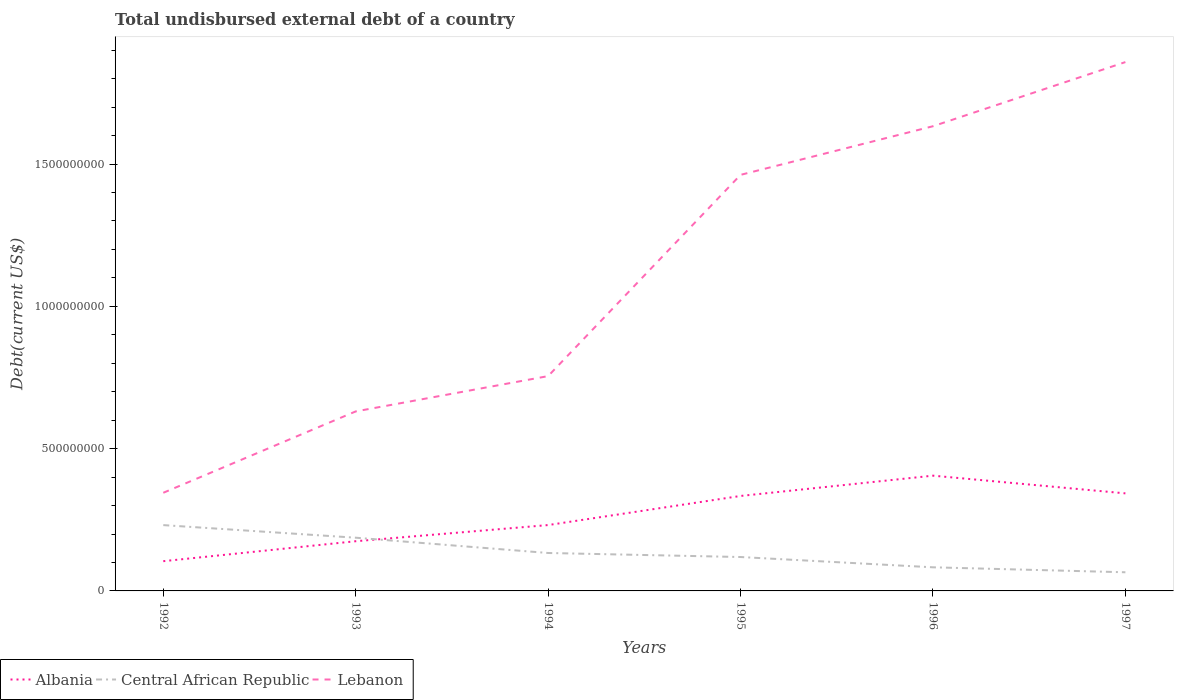Across all years, what is the maximum total undisbursed external debt in Albania?
Provide a short and direct response. 1.05e+08. What is the total total undisbursed external debt in Lebanon in the graph?
Your answer should be compact. -1.71e+08. What is the difference between the highest and the second highest total undisbursed external debt in Lebanon?
Offer a terse response. 1.51e+09. What is the difference between the highest and the lowest total undisbursed external debt in Central African Republic?
Offer a terse response. 2. How many years are there in the graph?
Ensure brevity in your answer.  6. Does the graph contain grids?
Give a very brief answer. No. How are the legend labels stacked?
Your response must be concise. Horizontal. What is the title of the graph?
Give a very brief answer. Total undisbursed external debt of a country. Does "Vanuatu" appear as one of the legend labels in the graph?
Ensure brevity in your answer.  No. What is the label or title of the X-axis?
Provide a succinct answer. Years. What is the label or title of the Y-axis?
Keep it short and to the point. Debt(current US$). What is the Debt(current US$) in Albania in 1992?
Keep it short and to the point. 1.05e+08. What is the Debt(current US$) in Central African Republic in 1992?
Keep it short and to the point. 2.31e+08. What is the Debt(current US$) in Lebanon in 1992?
Make the answer very short. 3.45e+08. What is the Debt(current US$) of Albania in 1993?
Your answer should be very brief. 1.75e+08. What is the Debt(current US$) of Central African Republic in 1993?
Give a very brief answer. 1.87e+08. What is the Debt(current US$) of Lebanon in 1993?
Your answer should be compact. 6.31e+08. What is the Debt(current US$) of Albania in 1994?
Your answer should be very brief. 2.31e+08. What is the Debt(current US$) of Central African Republic in 1994?
Your response must be concise. 1.33e+08. What is the Debt(current US$) of Lebanon in 1994?
Provide a short and direct response. 7.55e+08. What is the Debt(current US$) of Albania in 1995?
Give a very brief answer. 3.34e+08. What is the Debt(current US$) in Central African Republic in 1995?
Offer a terse response. 1.19e+08. What is the Debt(current US$) in Lebanon in 1995?
Give a very brief answer. 1.46e+09. What is the Debt(current US$) of Albania in 1996?
Offer a terse response. 4.05e+08. What is the Debt(current US$) of Central African Republic in 1996?
Your answer should be compact. 8.30e+07. What is the Debt(current US$) of Lebanon in 1996?
Offer a very short reply. 1.63e+09. What is the Debt(current US$) in Albania in 1997?
Give a very brief answer. 3.43e+08. What is the Debt(current US$) in Central African Republic in 1997?
Offer a very short reply. 6.55e+07. What is the Debt(current US$) in Lebanon in 1997?
Your answer should be very brief. 1.86e+09. Across all years, what is the maximum Debt(current US$) of Albania?
Give a very brief answer. 4.05e+08. Across all years, what is the maximum Debt(current US$) of Central African Republic?
Offer a terse response. 2.31e+08. Across all years, what is the maximum Debt(current US$) in Lebanon?
Provide a succinct answer. 1.86e+09. Across all years, what is the minimum Debt(current US$) in Albania?
Keep it short and to the point. 1.05e+08. Across all years, what is the minimum Debt(current US$) in Central African Republic?
Your response must be concise. 6.55e+07. Across all years, what is the minimum Debt(current US$) of Lebanon?
Offer a terse response. 3.45e+08. What is the total Debt(current US$) in Albania in the graph?
Offer a very short reply. 1.59e+09. What is the total Debt(current US$) of Central African Republic in the graph?
Keep it short and to the point. 8.19e+08. What is the total Debt(current US$) of Lebanon in the graph?
Your answer should be compact. 6.68e+09. What is the difference between the Debt(current US$) in Albania in 1992 and that in 1993?
Your response must be concise. -7.02e+07. What is the difference between the Debt(current US$) in Central African Republic in 1992 and that in 1993?
Offer a very short reply. 4.43e+07. What is the difference between the Debt(current US$) of Lebanon in 1992 and that in 1993?
Your answer should be compact. -2.86e+08. What is the difference between the Debt(current US$) in Albania in 1992 and that in 1994?
Offer a terse response. -1.27e+08. What is the difference between the Debt(current US$) of Central African Republic in 1992 and that in 1994?
Your response must be concise. 9.80e+07. What is the difference between the Debt(current US$) of Lebanon in 1992 and that in 1994?
Your response must be concise. -4.10e+08. What is the difference between the Debt(current US$) of Albania in 1992 and that in 1995?
Provide a succinct answer. -2.29e+08. What is the difference between the Debt(current US$) of Central African Republic in 1992 and that in 1995?
Provide a short and direct response. 1.12e+08. What is the difference between the Debt(current US$) of Lebanon in 1992 and that in 1995?
Give a very brief answer. -1.12e+09. What is the difference between the Debt(current US$) in Albania in 1992 and that in 1996?
Provide a succinct answer. -3.01e+08. What is the difference between the Debt(current US$) in Central African Republic in 1992 and that in 1996?
Your answer should be very brief. 1.48e+08. What is the difference between the Debt(current US$) in Lebanon in 1992 and that in 1996?
Your answer should be very brief. -1.29e+09. What is the difference between the Debt(current US$) of Albania in 1992 and that in 1997?
Ensure brevity in your answer.  -2.38e+08. What is the difference between the Debt(current US$) in Central African Republic in 1992 and that in 1997?
Offer a terse response. 1.66e+08. What is the difference between the Debt(current US$) of Lebanon in 1992 and that in 1997?
Keep it short and to the point. -1.51e+09. What is the difference between the Debt(current US$) of Albania in 1993 and that in 1994?
Provide a succinct answer. -5.68e+07. What is the difference between the Debt(current US$) in Central African Republic in 1993 and that in 1994?
Offer a terse response. 5.37e+07. What is the difference between the Debt(current US$) in Lebanon in 1993 and that in 1994?
Offer a terse response. -1.24e+08. What is the difference between the Debt(current US$) in Albania in 1993 and that in 1995?
Ensure brevity in your answer.  -1.59e+08. What is the difference between the Debt(current US$) of Central African Republic in 1993 and that in 1995?
Provide a short and direct response. 6.79e+07. What is the difference between the Debt(current US$) of Lebanon in 1993 and that in 1995?
Give a very brief answer. -8.31e+08. What is the difference between the Debt(current US$) in Albania in 1993 and that in 1996?
Your response must be concise. -2.30e+08. What is the difference between the Debt(current US$) in Central African Republic in 1993 and that in 1996?
Ensure brevity in your answer.  1.04e+08. What is the difference between the Debt(current US$) of Lebanon in 1993 and that in 1996?
Your answer should be compact. -1.00e+09. What is the difference between the Debt(current US$) in Albania in 1993 and that in 1997?
Your answer should be very brief. -1.68e+08. What is the difference between the Debt(current US$) of Central African Republic in 1993 and that in 1997?
Your answer should be very brief. 1.21e+08. What is the difference between the Debt(current US$) of Lebanon in 1993 and that in 1997?
Offer a very short reply. -1.23e+09. What is the difference between the Debt(current US$) in Albania in 1994 and that in 1995?
Your answer should be compact. -1.02e+08. What is the difference between the Debt(current US$) in Central African Republic in 1994 and that in 1995?
Give a very brief answer. 1.42e+07. What is the difference between the Debt(current US$) of Lebanon in 1994 and that in 1995?
Your answer should be compact. -7.07e+08. What is the difference between the Debt(current US$) of Albania in 1994 and that in 1996?
Make the answer very short. -1.74e+08. What is the difference between the Debt(current US$) of Central African Republic in 1994 and that in 1996?
Keep it short and to the point. 5.03e+07. What is the difference between the Debt(current US$) in Lebanon in 1994 and that in 1996?
Provide a short and direct response. -8.78e+08. What is the difference between the Debt(current US$) of Albania in 1994 and that in 1997?
Provide a short and direct response. -1.11e+08. What is the difference between the Debt(current US$) of Central African Republic in 1994 and that in 1997?
Ensure brevity in your answer.  6.78e+07. What is the difference between the Debt(current US$) of Lebanon in 1994 and that in 1997?
Offer a terse response. -1.10e+09. What is the difference between the Debt(current US$) of Albania in 1995 and that in 1996?
Provide a succinct answer. -7.13e+07. What is the difference between the Debt(current US$) of Central African Republic in 1995 and that in 1996?
Keep it short and to the point. 3.62e+07. What is the difference between the Debt(current US$) in Lebanon in 1995 and that in 1996?
Make the answer very short. -1.71e+08. What is the difference between the Debt(current US$) in Albania in 1995 and that in 1997?
Your response must be concise. -9.08e+06. What is the difference between the Debt(current US$) of Central African Republic in 1995 and that in 1997?
Your answer should be very brief. 5.36e+07. What is the difference between the Debt(current US$) of Lebanon in 1995 and that in 1997?
Ensure brevity in your answer.  -3.96e+08. What is the difference between the Debt(current US$) in Albania in 1996 and that in 1997?
Your answer should be compact. 6.22e+07. What is the difference between the Debt(current US$) in Central African Republic in 1996 and that in 1997?
Give a very brief answer. 1.74e+07. What is the difference between the Debt(current US$) in Lebanon in 1996 and that in 1997?
Offer a very short reply. -2.25e+08. What is the difference between the Debt(current US$) of Albania in 1992 and the Debt(current US$) of Central African Republic in 1993?
Provide a short and direct response. -8.25e+07. What is the difference between the Debt(current US$) in Albania in 1992 and the Debt(current US$) in Lebanon in 1993?
Make the answer very short. -5.26e+08. What is the difference between the Debt(current US$) of Central African Republic in 1992 and the Debt(current US$) of Lebanon in 1993?
Provide a short and direct response. -4.00e+08. What is the difference between the Debt(current US$) of Albania in 1992 and the Debt(current US$) of Central African Republic in 1994?
Keep it short and to the point. -2.88e+07. What is the difference between the Debt(current US$) in Albania in 1992 and the Debt(current US$) in Lebanon in 1994?
Provide a short and direct response. -6.50e+08. What is the difference between the Debt(current US$) of Central African Republic in 1992 and the Debt(current US$) of Lebanon in 1994?
Give a very brief answer. -5.24e+08. What is the difference between the Debt(current US$) of Albania in 1992 and the Debt(current US$) of Central African Republic in 1995?
Your answer should be compact. -1.46e+07. What is the difference between the Debt(current US$) of Albania in 1992 and the Debt(current US$) of Lebanon in 1995?
Ensure brevity in your answer.  -1.36e+09. What is the difference between the Debt(current US$) of Central African Republic in 1992 and the Debt(current US$) of Lebanon in 1995?
Ensure brevity in your answer.  -1.23e+09. What is the difference between the Debt(current US$) in Albania in 1992 and the Debt(current US$) in Central African Republic in 1996?
Your answer should be very brief. 2.15e+07. What is the difference between the Debt(current US$) of Albania in 1992 and the Debt(current US$) of Lebanon in 1996?
Make the answer very short. -1.53e+09. What is the difference between the Debt(current US$) in Central African Republic in 1992 and the Debt(current US$) in Lebanon in 1996?
Your response must be concise. -1.40e+09. What is the difference between the Debt(current US$) in Albania in 1992 and the Debt(current US$) in Central African Republic in 1997?
Provide a short and direct response. 3.90e+07. What is the difference between the Debt(current US$) in Albania in 1992 and the Debt(current US$) in Lebanon in 1997?
Your answer should be compact. -1.75e+09. What is the difference between the Debt(current US$) of Central African Republic in 1992 and the Debt(current US$) of Lebanon in 1997?
Provide a short and direct response. -1.63e+09. What is the difference between the Debt(current US$) in Albania in 1993 and the Debt(current US$) in Central African Republic in 1994?
Your answer should be very brief. 4.14e+07. What is the difference between the Debt(current US$) of Albania in 1993 and the Debt(current US$) of Lebanon in 1994?
Offer a very short reply. -5.80e+08. What is the difference between the Debt(current US$) of Central African Republic in 1993 and the Debt(current US$) of Lebanon in 1994?
Provide a succinct answer. -5.68e+08. What is the difference between the Debt(current US$) in Albania in 1993 and the Debt(current US$) in Central African Republic in 1995?
Provide a short and direct response. 5.55e+07. What is the difference between the Debt(current US$) in Albania in 1993 and the Debt(current US$) in Lebanon in 1995?
Ensure brevity in your answer.  -1.29e+09. What is the difference between the Debt(current US$) in Central African Republic in 1993 and the Debt(current US$) in Lebanon in 1995?
Give a very brief answer. -1.28e+09. What is the difference between the Debt(current US$) in Albania in 1993 and the Debt(current US$) in Central African Republic in 1996?
Offer a very short reply. 9.17e+07. What is the difference between the Debt(current US$) of Albania in 1993 and the Debt(current US$) of Lebanon in 1996?
Provide a succinct answer. -1.46e+09. What is the difference between the Debt(current US$) of Central African Republic in 1993 and the Debt(current US$) of Lebanon in 1996?
Provide a short and direct response. -1.45e+09. What is the difference between the Debt(current US$) in Albania in 1993 and the Debt(current US$) in Central African Republic in 1997?
Make the answer very short. 1.09e+08. What is the difference between the Debt(current US$) in Albania in 1993 and the Debt(current US$) in Lebanon in 1997?
Keep it short and to the point. -1.68e+09. What is the difference between the Debt(current US$) of Central African Republic in 1993 and the Debt(current US$) of Lebanon in 1997?
Offer a very short reply. -1.67e+09. What is the difference between the Debt(current US$) of Albania in 1994 and the Debt(current US$) of Central African Republic in 1995?
Your response must be concise. 1.12e+08. What is the difference between the Debt(current US$) in Albania in 1994 and the Debt(current US$) in Lebanon in 1995?
Ensure brevity in your answer.  -1.23e+09. What is the difference between the Debt(current US$) in Central African Republic in 1994 and the Debt(current US$) in Lebanon in 1995?
Offer a very short reply. -1.33e+09. What is the difference between the Debt(current US$) of Albania in 1994 and the Debt(current US$) of Central African Republic in 1996?
Your answer should be very brief. 1.48e+08. What is the difference between the Debt(current US$) of Albania in 1994 and the Debt(current US$) of Lebanon in 1996?
Offer a very short reply. -1.40e+09. What is the difference between the Debt(current US$) of Central African Republic in 1994 and the Debt(current US$) of Lebanon in 1996?
Your answer should be compact. -1.50e+09. What is the difference between the Debt(current US$) of Albania in 1994 and the Debt(current US$) of Central African Republic in 1997?
Ensure brevity in your answer.  1.66e+08. What is the difference between the Debt(current US$) in Albania in 1994 and the Debt(current US$) in Lebanon in 1997?
Your response must be concise. -1.63e+09. What is the difference between the Debt(current US$) in Central African Republic in 1994 and the Debt(current US$) in Lebanon in 1997?
Your response must be concise. -1.73e+09. What is the difference between the Debt(current US$) in Albania in 1995 and the Debt(current US$) in Central African Republic in 1996?
Give a very brief answer. 2.51e+08. What is the difference between the Debt(current US$) in Albania in 1995 and the Debt(current US$) in Lebanon in 1996?
Your response must be concise. -1.30e+09. What is the difference between the Debt(current US$) of Central African Republic in 1995 and the Debt(current US$) of Lebanon in 1996?
Offer a terse response. -1.51e+09. What is the difference between the Debt(current US$) of Albania in 1995 and the Debt(current US$) of Central African Republic in 1997?
Ensure brevity in your answer.  2.68e+08. What is the difference between the Debt(current US$) of Albania in 1995 and the Debt(current US$) of Lebanon in 1997?
Ensure brevity in your answer.  -1.52e+09. What is the difference between the Debt(current US$) in Central African Republic in 1995 and the Debt(current US$) in Lebanon in 1997?
Give a very brief answer. -1.74e+09. What is the difference between the Debt(current US$) in Albania in 1996 and the Debt(current US$) in Central African Republic in 1997?
Your answer should be compact. 3.40e+08. What is the difference between the Debt(current US$) of Albania in 1996 and the Debt(current US$) of Lebanon in 1997?
Your answer should be compact. -1.45e+09. What is the difference between the Debt(current US$) of Central African Republic in 1996 and the Debt(current US$) of Lebanon in 1997?
Offer a terse response. -1.78e+09. What is the average Debt(current US$) in Albania per year?
Provide a short and direct response. 2.65e+08. What is the average Debt(current US$) of Central African Republic per year?
Give a very brief answer. 1.37e+08. What is the average Debt(current US$) of Lebanon per year?
Your answer should be compact. 1.11e+09. In the year 1992, what is the difference between the Debt(current US$) in Albania and Debt(current US$) in Central African Republic?
Your answer should be compact. -1.27e+08. In the year 1992, what is the difference between the Debt(current US$) in Albania and Debt(current US$) in Lebanon?
Keep it short and to the point. -2.40e+08. In the year 1992, what is the difference between the Debt(current US$) in Central African Republic and Debt(current US$) in Lebanon?
Keep it short and to the point. -1.14e+08. In the year 1993, what is the difference between the Debt(current US$) of Albania and Debt(current US$) of Central African Republic?
Offer a terse response. -1.23e+07. In the year 1993, what is the difference between the Debt(current US$) of Albania and Debt(current US$) of Lebanon?
Make the answer very short. -4.56e+08. In the year 1993, what is the difference between the Debt(current US$) in Central African Republic and Debt(current US$) in Lebanon?
Give a very brief answer. -4.44e+08. In the year 1994, what is the difference between the Debt(current US$) of Albania and Debt(current US$) of Central African Republic?
Your answer should be very brief. 9.81e+07. In the year 1994, what is the difference between the Debt(current US$) in Albania and Debt(current US$) in Lebanon?
Make the answer very short. -5.23e+08. In the year 1994, what is the difference between the Debt(current US$) of Central African Republic and Debt(current US$) of Lebanon?
Provide a succinct answer. -6.22e+08. In the year 1995, what is the difference between the Debt(current US$) in Albania and Debt(current US$) in Central African Republic?
Make the answer very short. 2.15e+08. In the year 1995, what is the difference between the Debt(current US$) in Albania and Debt(current US$) in Lebanon?
Provide a short and direct response. -1.13e+09. In the year 1995, what is the difference between the Debt(current US$) of Central African Republic and Debt(current US$) of Lebanon?
Give a very brief answer. -1.34e+09. In the year 1996, what is the difference between the Debt(current US$) in Albania and Debt(current US$) in Central African Republic?
Your response must be concise. 3.22e+08. In the year 1996, what is the difference between the Debt(current US$) in Albania and Debt(current US$) in Lebanon?
Give a very brief answer. -1.23e+09. In the year 1996, what is the difference between the Debt(current US$) of Central African Republic and Debt(current US$) of Lebanon?
Offer a terse response. -1.55e+09. In the year 1997, what is the difference between the Debt(current US$) in Albania and Debt(current US$) in Central African Republic?
Offer a very short reply. 2.77e+08. In the year 1997, what is the difference between the Debt(current US$) in Albania and Debt(current US$) in Lebanon?
Your response must be concise. -1.52e+09. In the year 1997, what is the difference between the Debt(current US$) in Central African Republic and Debt(current US$) in Lebanon?
Your response must be concise. -1.79e+09. What is the ratio of the Debt(current US$) in Albania in 1992 to that in 1993?
Keep it short and to the point. 0.6. What is the ratio of the Debt(current US$) in Central African Republic in 1992 to that in 1993?
Offer a very short reply. 1.24. What is the ratio of the Debt(current US$) of Lebanon in 1992 to that in 1993?
Your response must be concise. 0.55. What is the ratio of the Debt(current US$) of Albania in 1992 to that in 1994?
Your response must be concise. 0.45. What is the ratio of the Debt(current US$) in Central African Republic in 1992 to that in 1994?
Your answer should be compact. 1.74. What is the ratio of the Debt(current US$) of Lebanon in 1992 to that in 1994?
Ensure brevity in your answer.  0.46. What is the ratio of the Debt(current US$) in Albania in 1992 to that in 1995?
Offer a very short reply. 0.31. What is the ratio of the Debt(current US$) in Central African Republic in 1992 to that in 1995?
Your answer should be very brief. 1.94. What is the ratio of the Debt(current US$) of Lebanon in 1992 to that in 1995?
Provide a succinct answer. 0.24. What is the ratio of the Debt(current US$) of Albania in 1992 to that in 1996?
Provide a short and direct response. 0.26. What is the ratio of the Debt(current US$) of Central African Republic in 1992 to that in 1996?
Offer a very short reply. 2.79. What is the ratio of the Debt(current US$) in Lebanon in 1992 to that in 1996?
Offer a terse response. 0.21. What is the ratio of the Debt(current US$) of Albania in 1992 to that in 1997?
Provide a succinct answer. 0.3. What is the ratio of the Debt(current US$) in Central African Republic in 1992 to that in 1997?
Offer a very short reply. 3.53. What is the ratio of the Debt(current US$) of Lebanon in 1992 to that in 1997?
Your answer should be very brief. 0.19. What is the ratio of the Debt(current US$) in Albania in 1993 to that in 1994?
Offer a terse response. 0.75. What is the ratio of the Debt(current US$) in Central African Republic in 1993 to that in 1994?
Your answer should be compact. 1.4. What is the ratio of the Debt(current US$) in Lebanon in 1993 to that in 1994?
Ensure brevity in your answer.  0.84. What is the ratio of the Debt(current US$) of Albania in 1993 to that in 1995?
Your answer should be compact. 0.52. What is the ratio of the Debt(current US$) in Central African Republic in 1993 to that in 1995?
Provide a succinct answer. 1.57. What is the ratio of the Debt(current US$) in Lebanon in 1993 to that in 1995?
Keep it short and to the point. 0.43. What is the ratio of the Debt(current US$) in Albania in 1993 to that in 1996?
Offer a terse response. 0.43. What is the ratio of the Debt(current US$) of Central African Republic in 1993 to that in 1996?
Offer a terse response. 2.25. What is the ratio of the Debt(current US$) in Lebanon in 1993 to that in 1996?
Keep it short and to the point. 0.39. What is the ratio of the Debt(current US$) of Albania in 1993 to that in 1997?
Keep it short and to the point. 0.51. What is the ratio of the Debt(current US$) in Central African Republic in 1993 to that in 1997?
Your answer should be compact. 2.85. What is the ratio of the Debt(current US$) in Lebanon in 1993 to that in 1997?
Your response must be concise. 0.34. What is the ratio of the Debt(current US$) of Albania in 1994 to that in 1995?
Your answer should be very brief. 0.69. What is the ratio of the Debt(current US$) in Central African Republic in 1994 to that in 1995?
Offer a terse response. 1.12. What is the ratio of the Debt(current US$) in Lebanon in 1994 to that in 1995?
Offer a very short reply. 0.52. What is the ratio of the Debt(current US$) in Central African Republic in 1994 to that in 1996?
Offer a terse response. 1.61. What is the ratio of the Debt(current US$) of Lebanon in 1994 to that in 1996?
Ensure brevity in your answer.  0.46. What is the ratio of the Debt(current US$) of Albania in 1994 to that in 1997?
Provide a short and direct response. 0.68. What is the ratio of the Debt(current US$) in Central African Republic in 1994 to that in 1997?
Your answer should be compact. 2.03. What is the ratio of the Debt(current US$) in Lebanon in 1994 to that in 1997?
Your answer should be compact. 0.41. What is the ratio of the Debt(current US$) of Albania in 1995 to that in 1996?
Keep it short and to the point. 0.82. What is the ratio of the Debt(current US$) in Central African Republic in 1995 to that in 1996?
Make the answer very short. 1.44. What is the ratio of the Debt(current US$) of Lebanon in 1995 to that in 1996?
Offer a very short reply. 0.9. What is the ratio of the Debt(current US$) in Albania in 1995 to that in 1997?
Make the answer very short. 0.97. What is the ratio of the Debt(current US$) in Central African Republic in 1995 to that in 1997?
Your answer should be compact. 1.82. What is the ratio of the Debt(current US$) in Lebanon in 1995 to that in 1997?
Your answer should be very brief. 0.79. What is the ratio of the Debt(current US$) of Albania in 1996 to that in 1997?
Ensure brevity in your answer.  1.18. What is the ratio of the Debt(current US$) in Central African Republic in 1996 to that in 1997?
Provide a short and direct response. 1.27. What is the ratio of the Debt(current US$) of Lebanon in 1996 to that in 1997?
Keep it short and to the point. 0.88. What is the difference between the highest and the second highest Debt(current US$) in Albania?
Offer a terse response. 6.22e+07. What is the difference between the highest and the second highest Debt(current US$) in Central African Republic?
Ensure brevity in your answer.  4.43e+07. What is the difference between the highest and the second highest Debt(current US$) of Lebanon?
Your response must be concise. 2.25e+08. What is the difference between the highest and the lowest Debt(current US$) of Albania?
Ensure brevity in your answer.  3.01e+08. What is the difference between the highest and the lowest Debt(current US$) in Central African Republic?
Provide a succinct answer. 1.66e+08. What is the difference between the highest and the lowest Debt(current US$) in Lebanon?
Give a very brief answer. 1.51e+09. 